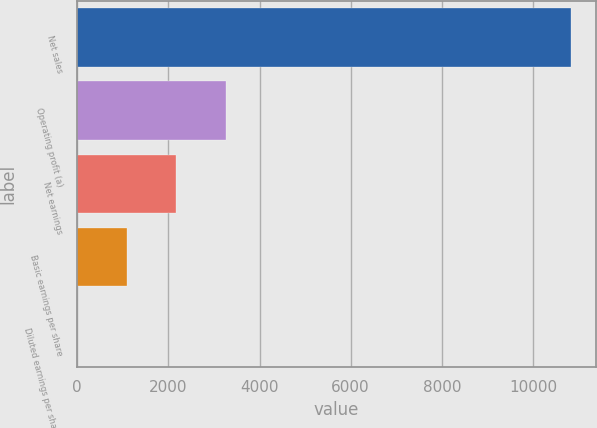Convert chart. <chart><loc_0><loc_0><loc_500><loc_500><bar_chart><fcel>Net sales<fcel>Operating profit (a)<fcel>Net earnings<fcel>Basic earnings per share<fcel>Diluted earnings per share (b)<nl><fcel>10841<fcel>3253.62<fcel>2169.71<fcel>1085.8<fcel>1.89<nl></chart> 